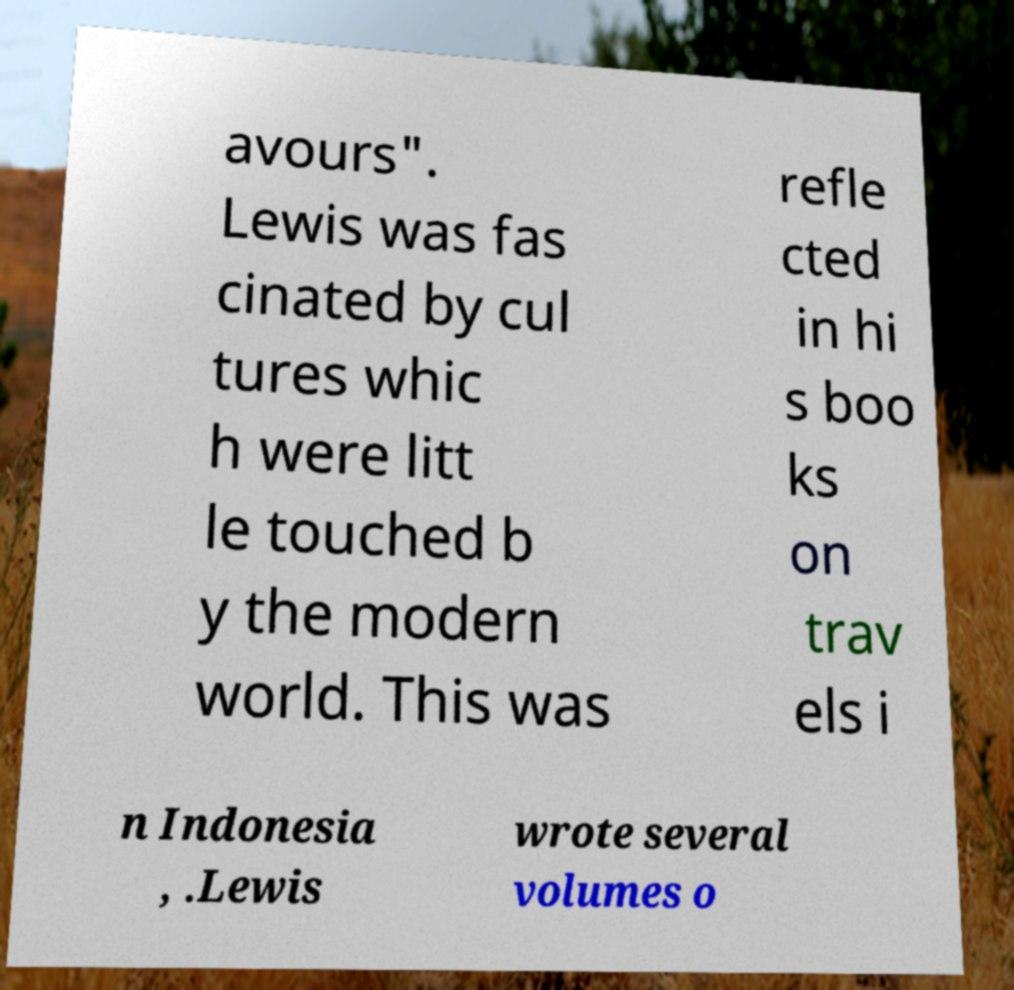For documentation purposes, I need the text within this image transcribed. Could you provide that? avours". Lewis was fas cinated by cul tures whic h were litt le touched b y the modern world. This was refle cted in hi s boo ks on trav els i n Indonesia , .Lewis wrote several volumes o 